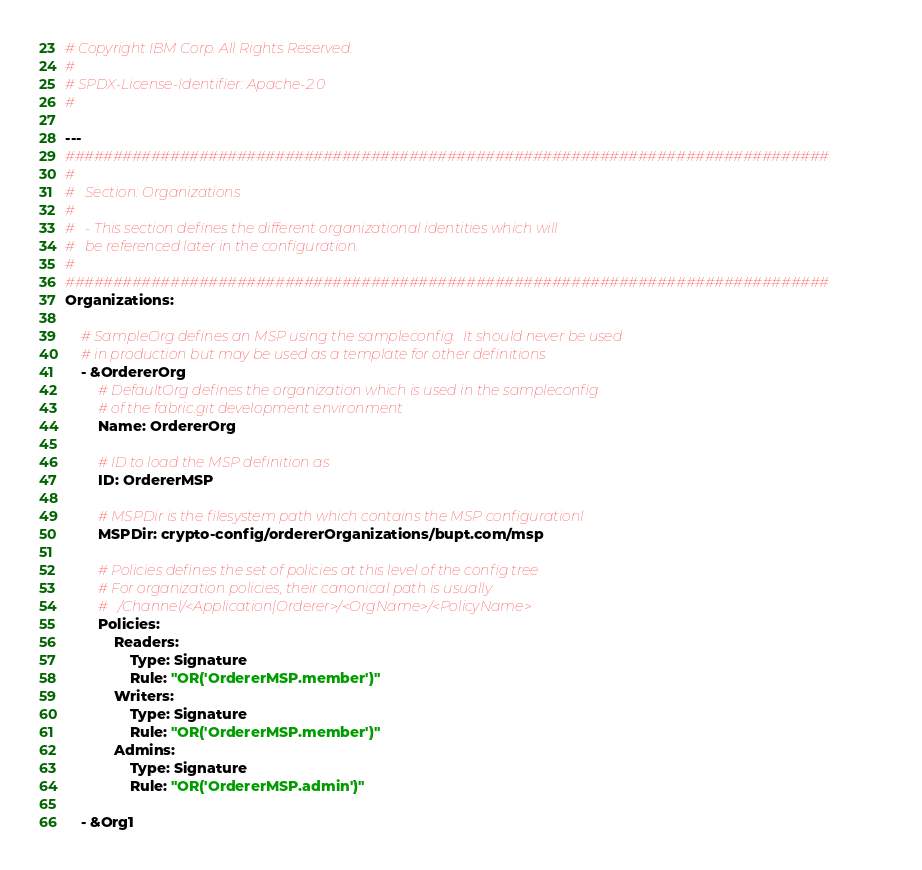Convert code to text. <code><loc_0><loc_0><loc_500><loc_500><_YAML_># Copyright IBM Corp. All Rights Reserved.
#
# SPDX-License-Identifier: Apache-2.0
#

---
################################################################################
#
#   Section: Organizations
#
#   - This section defines the different organizational identities which will
#   be referenced later in the configuration.
#
################################################################################
Organizations:

    # SampleOrg defines an MSP using the sampleconfig.  It should never be used
    # in production but may be used as a template for other definitions
    - &OrdererOrg
        # DefaultOrg defines the organization which is used in the sampleconfig
        # of the fabric.git development environment
        Name: OrdererOrg

        # ID to load the MSP definition as
        ID: OrdererMSP

        # MSPDir is the filesystem path which contains the MSP configurationl
        MSPDir: crypto-config/ordererOrganizations/bupt.com/msp

        # Policies defines the set of policies at this level of the config tree
        # For organization policies, their canonical path is usually
        #   /Channel/<Application|Orderer>/<OrgName>/<PolicyName>
        Policies:
            Readers:
                Type: Signature
                Rule: "OR('OrdererMSP.member')"
            Writers:
                Type: Signature
                Rule: "OR('OrdererMSP.member')"
            Admins:
                Type: Signature
                Rule: "OR('OrdererMSP.admin')"

    - &Org1</code> 